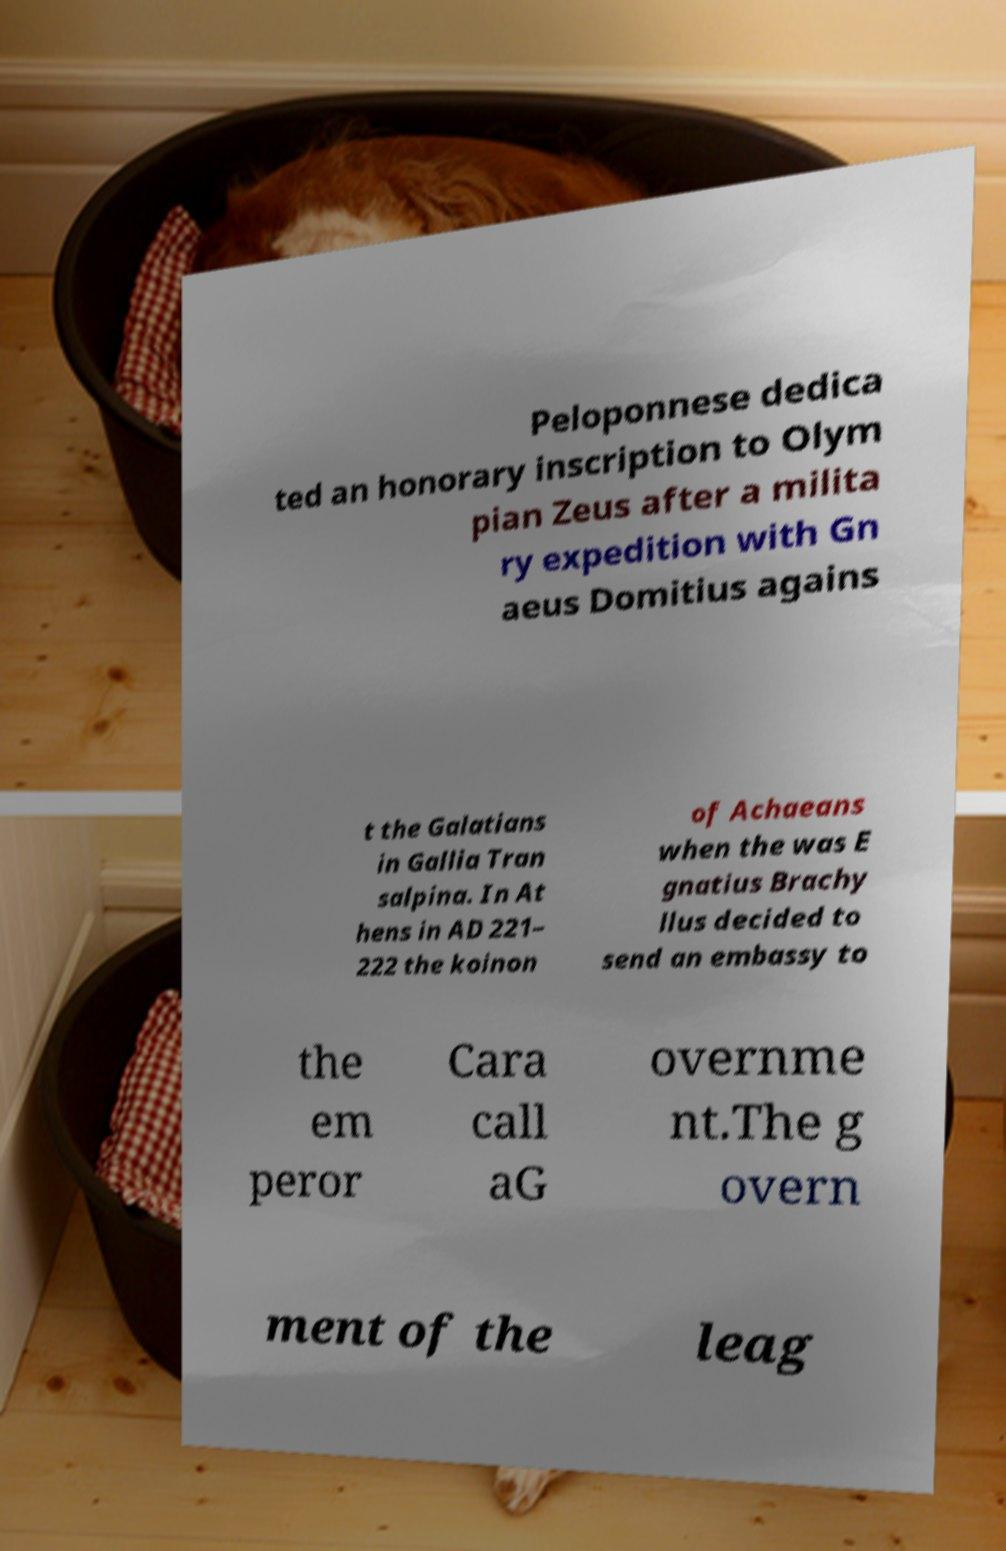For documentation purposes, I need the text within this image transcribed. Could you provide that? Peloponnese dedica ted an honorary inscription to Olym pian Zeus after a milita ry expedition with Gn aeus Domitius agains t the Galatians in Gallia Tran salpina. In At hens in AD 221– 222 the koinon of Achaeans when the was E gnatius Brachy llus decided to send an embassy to the em peror Cara call aG overnme nt.The g overn ment of the leag 